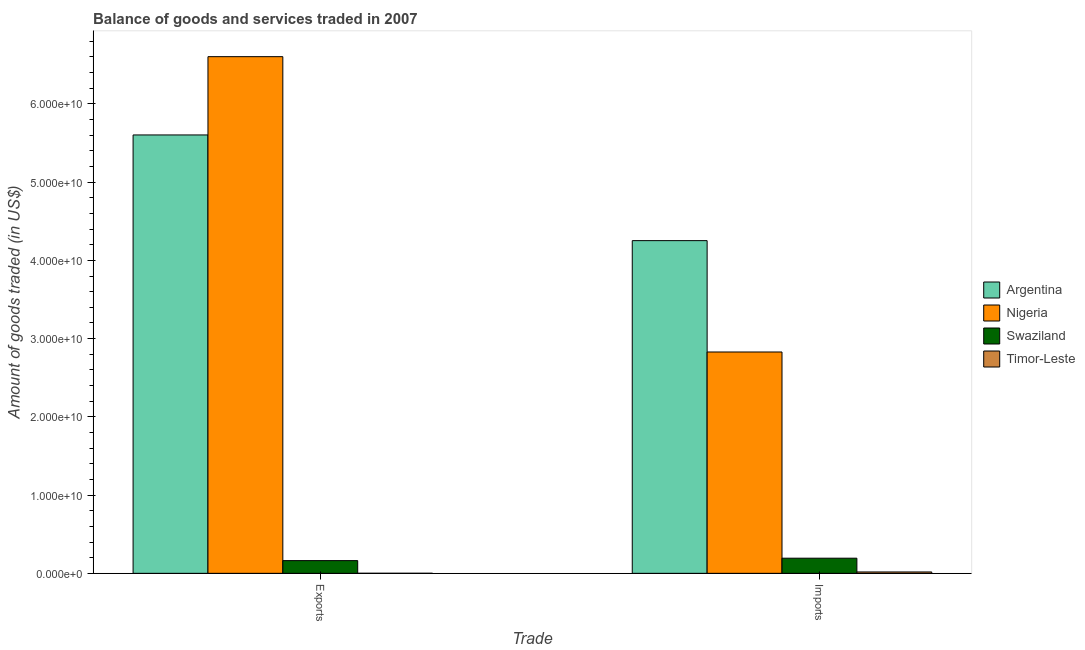How many different coloured bars are there?
Your answer should be very brief. 4. How many groups of bars are there?
Provide a short and direct response. 2. Are the number of bars per tick equal to the number of legend labels?
Your answer should be very brief. Yes. Are the number of bars on each tick of the X-axis equal?
Keep it short and to the point. Yes. How many bars are there on the 2nd tick from the left?
Provide a succinct answer. 4. What is the label of the 1st group of bars from the left?
Give a very brief answer. Exports. What is the amount of goods imported in Timor-Leste?
Provide a short and direct response. 1.76e+08. Across all countries, what is the maximum amount of goods exported?
Your answer should be compact. 6.60e+1. Across all countries, what is the minimum amount of goods imported?
Provide a succinct answer. 1.76e+08. In which country was the amount of goods imported maximum?
Your response must be concise. Argentina. In which country was the amount of goods imported minimum?
Offer a terse response. Timor-Leste. What is the total amount of goods imported in the graph?
Ensure brevity in your answer.  7.29e+1. What is the difference between the amount of goods exported in Timor-Leste and that in Nigeria?
Make the answer very short. -6.60e+1. What is the difference between the amount of goods exported in Timor-Leste and the amount of goods imported in Swaziland?
Make the answer very short. -1.93e+09. What is the average amount of goods exported per country?
Provide a succinct answer. 3.09e+1. What is the difference between the amount of goods exported and amount of goods imported in Argentina?
Ensure brevity in your answer.  1.35e+1. What is the ratio of the amount of goods imported in Swaziland to that in Nigeria?
Ensure brevity in your answer.  0.07. In how many countries, is the amount of goods exported greater than the average amount of goods exported taken over all countries?
Ensure brevity in your answer.  2. What does the 4th bar from the left in Exports represents?
Make the answer very short. Timor-Leste. What does the 4th bar from the right in Imports represents?
Your answer should be very brief. Argentina. Are all the bars in the graph horizontal?
Your response must be concise. No. Does the graph contain grids?
Your answer should be very brief. No. How many legend labels are there?
Ensure brevity in your answer.  4. How are the legend labels stacked?
Give a very brief answer. Vertical. What is the title of the graph?
Provide a short and direct response. Balance of goods and services traded in 2007. Does "Gabon" appear as one of the legend labels in the graph?
Give a very brief answer. No. What is the label or title of the X-axis?
Keep it short and to the point. Trade. What is the label or title of the Y-axis?
Offer a terse response. Amount of goods traded (in US$). What is the Amount of goods traded (in US$) in Argentina in Exports?
Offer a very short reply. 5.60e+1. What is the Amount of goods traded (in US$) in Nigeria in Exports?
Keep it short and to the point. 6.60e+1. What is the Amount of goods traded (in US$) in Swaziland in Exports?
Make the answer very short. 1.63e+09. What is the Amount of goods traded (in US$) of Timor-Leste in Exports?
Ensure brevity in your answer.  6.65e+06. What is the Amount of goods traded (in US$) of Argentina in Imports?
Give a very brief answer. 4.25e+1. What is the Amount of goods traded (in US$) in Nigeria in Imports?
Provide a succinct answer. 2.83e+1. What is the Amount of goods traded (in US$) of Swaziland in Imports?
Make the answer very short. 1.93e+09. What is the Amount of goods traded (in US$) in Timor-Leste in Imports?
Offer a terse response. 1.76e+08. Across all Trade, what is the maximum Amount of goods traded (in US$) in Argentina?
Keep it short and to the point. 5.60e+1. Across all Trade, what is the maximum Amount of goods traded (in US$) in Nigeria?
Provide a succinct answer. 6.60e+1. Across all Trade, what is the maximum Amount of goods traded (in US$) of Swaziland?
Provide a succinct answer. 1.93e+09. Across all Trade, what is the maximum Amount of goods traded (in US$) in Timor-Leste?
Offer a terse response. 1.76e+08. Across all Trade, what is the minimum Amount of goods traded (in US$) in Argentina?
Ensure brevity in your answer.  4.25e+1. Across all Trade, what is the minimum Amount of goods traded (in US$) of Nigeria?
Offer a very short reply. 2.83e+1. Across all Trade, what is the minimum Amount of goods traded (in US$) of Swaziland?
Offer a very short reply. 1.63e+09. Across all Trade, what is the minimum Amount of goods traded (in US$) in Timor-Leste?
Provide a short and direct response. 6.65e+06. What is the total Amount of goods traded (in US$) in Argentina in the graph?
Offer a terse response. 9.86e+1. What is the total Amount of goods traded (in US$) in Nigeria in the graph?
Your response must be concise. 9.43e+1. What is the total Amount of goods traded (in US$) of Swaziland in the graph?
Your response must be concise. 3.56e+09. What is the total Amount of goods traded (in US$) of Timor-Leste in the graph?
Keep it short and to the point. 1.82e+08. What is the difference between the Amount of goods traded (in US$) in Argentina in Exports and that in Imports?
Offer a terse response. 1.35e+1. What is the difference between the Amount of goods traded (in US$) in Nigeria in Exports and that in Imports?
Keep it short and to the point. 3.77e+1. What is the difference between the Amount of goods traded (in US$) in Swaziland in Exports and that in Imports?
Give a very brief answer. -3.09e+08. What is the difference between the Amount of goods traded (in US$) of Timor-Leste in Exports and that in Imports?
Make the answer very short. -1.69e+08. What is the difference between the Amount of goods traded (in US$) of Argentina in Exports and the Amount of goods traded (in US$) of Nigeria in Imports?
Keep it short and to the point. 2.77e+1. What is the difference between the Amount of goods traded (in US$) of Argentina in Exports and the Amount of goods traded (in US$) of Swaziland in Imports?
Make the answer very short. 5.41e+1. What is the difference between the Amount of goods traded (in US$) in Argentina in Exports and the Amount of goods traded (in US$) in Timor-Leste in Imports?
Give a very brief answer. 5.59e+1. What is the difference between the Amount of goods traded (in US$) of Nigeria in Exports and the Amount of goods traded (in US$) of Swaziland in Imports?
Ensure brevity in your answer.  6.41e+1. What is the difference between the Amount of goods traded (in US$) of Nigeria in Exports and the Amount of goods traded (in US$) of Timor-Leste in Imports?
Give a very brief answer. 6.59e+1. What is the difference between the Amount of goods traded (in US$) in Swaziland in Exports and the Amount of goods traded (in US$) in Timor-Leste in Imports?
Provide a short and direct response. 1.45e+09. What is the average Amount of goods traded (in US$) of Argentina per Trade?
Your response must be concise. 4.93e+1. What is the average Amount of goods traded (in US$) in Nigeria per Trade?
Your response must be concise. 4.72e+1. What is the average Amount of goods traded (in US$) in Swaziland per Trade?
Keep it short and to the point. 1.78e+09. What is the average Amount of goods traded (in US$) in Timor-Leste per Trade?
Provide a succinct answer. 9.12e+07. What is the difference between the Amount of goods traded (in US$) of Argentina and Amount of goods traded (in US$) of Nigeria in Exports?
Offer a very short reply. -1.00e+1. What is the difference between the Amount of goods traded (in US$) of Argentina and Amount of goods traded (in US$) of Swaziland in Exports?
Provide a succinct answer. 5.44e+1. What is the difference between the Amount of goods traded (in US$) in Argentina and Amount of goods traded (in US$) in Timor-Leste in Exports?
Ensure brevity in your answer.  5.60e+1. What is the difference between the Amount of goods traded (in US$) in Nigeria and Amount of goods traded (in US$) in Swaziland in Exports?
Ensure brevity in your answer.  6.44e+1. What is the difference between the Amount of goods traded (in US$) of Nigeria and Amount of goods traded (in US$) of Timor-Leste in Exports?
Your response must be concise. 6.60e+1. What is the difference between the Amount of goods traded (in US$) in Swaziland and Amount of goods traded (in US$) in Timor-Leste in Exports?
Provide a short and direct response. 1.62e+09. What is the difference between the Amount of goods traded (in US$) of Argentina and Amount of goods traded (in US$) of Nigeria in Imports?
Ensure brevity in your answer.  1.42e+1. What is the difference between the Amount of goods traded (in US$) of Argentina and Amount of goods traded (in US$) of Swaziland in Imports?
Make the answer very short. 4.06e+1. What is the difference between the Amount of goods traded (in US$) in Argentina and Amount of goods traded (in US$) in Timor-Leste in Imports?
Keep it short and to the point. 4.23e+1. What is the difference between the Amount of goods traded (in US$) of Nigeria and Amount of goods traded (in US$) of Swaziland in Imports?
Ensure brevity in your answer.  2.64e+1. What is the difference between the Amount of goods traded (in US$) in Nigeria and Amount of goods traded (in US$) in Timor-Leste in Imports?
Make the answer very short. 2.81e+1. What is the difference between the Amount of goods traded (in US$) in Swaziland and Amount of goods traded (in US$) in Timor-Leste in Imports?
Ensure brevity in your answer.  1.76e+09. What is the ratio of the Amount of goods traded (in US$) in Argentina in Exports to that in Imports?
Offer a terse response. 1.32. What is the ratio of the Amount of goods traded (in US$) in Nigeria in Exports to that in Imports?
Your response must be concise. 2.33. What is the ratio of the Amount of goods traded (in US$) of Swaziland in Exports to that in Imports?
Provide a succinct answer. 0.84. What is the ratio of the Amount of goods traded (in US$) in Timor-Leste in Exports to that in Imports?
Ensure brevity in your answer.  0.04. What is the difference between the highest and the second highest Amount of goods traded (in US$) in Argentina?
Ensure brevity in your answer.  1.35e+1. What is the difference between the highest and the second highest Amount of goods traded (in US$) in Nigeria?
Offer a very short reply. 3.77e+1. What is the difference between the highest and the second highest Amount of goods traded (in US$) in Swaziland?
Offer a very short reply. 3.09e+08. What is the difference between the highest and the second highest Amount of goods traded (in US$) in Timor-Leste?
Provide a short and direct response. 1.69e+08. What is the difference between the highest and the lowest Amount of goods traded (in US$) of Argentina?
Your answer should be very brief. 1.35e+1. What is the difference between the highest and the lowest Amount of goods traded (in US$) in Nigeria?
Offer a very short reply. 3.77e+1. What is the difference between the highest and the lowest Amount of goods traded (in US$) in Swaziland?
Give a very brief answer. 3.09e+08. What is the difference between the highest and the lowest Amount of goods traded (in US$) in Timor-Leste?
Provide a short and direct response. 1.69e+08. 